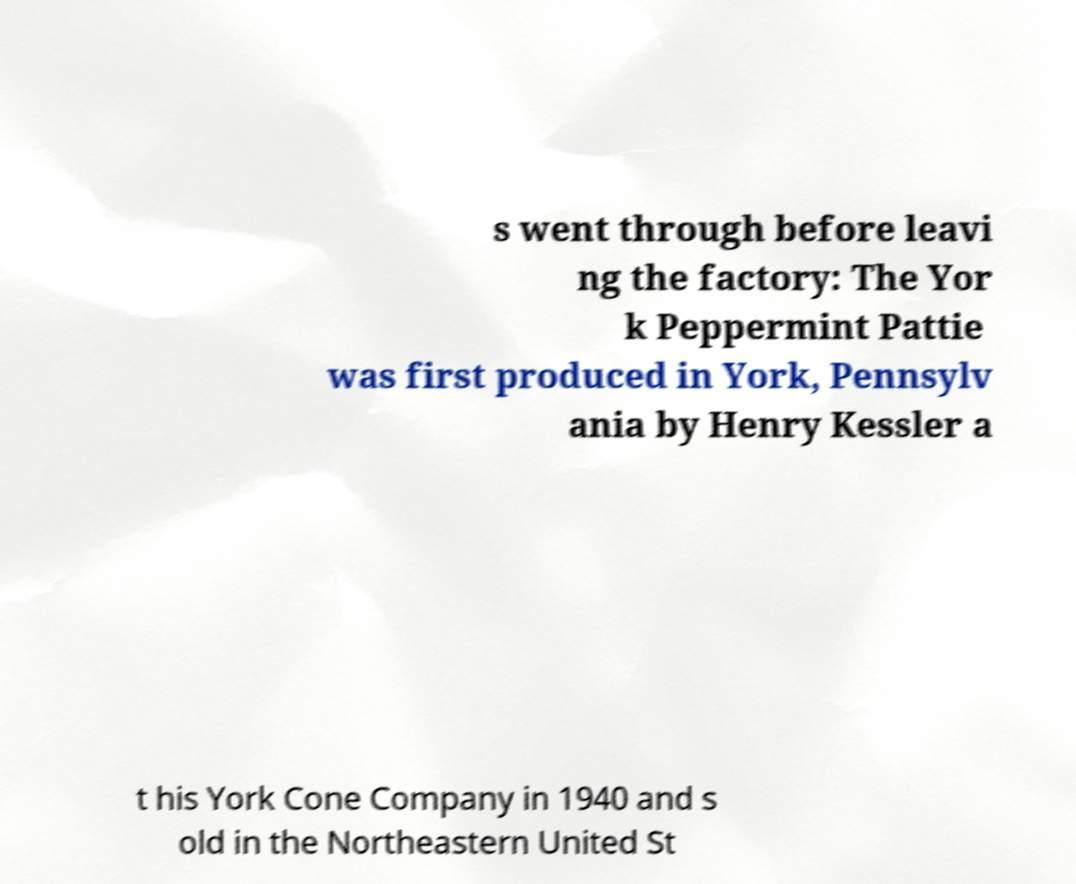Can you read and provide the text displayed in the image?This photo seems to have some interesting text. Can you extract and type it out for me? s went through before leavi ng the factory: The Yor k Peppermint Pattie was first produced in York, Pennsylv ania by Henry Kessler a t his York Cone Company in 1940 and s old in the Northeastern United St 